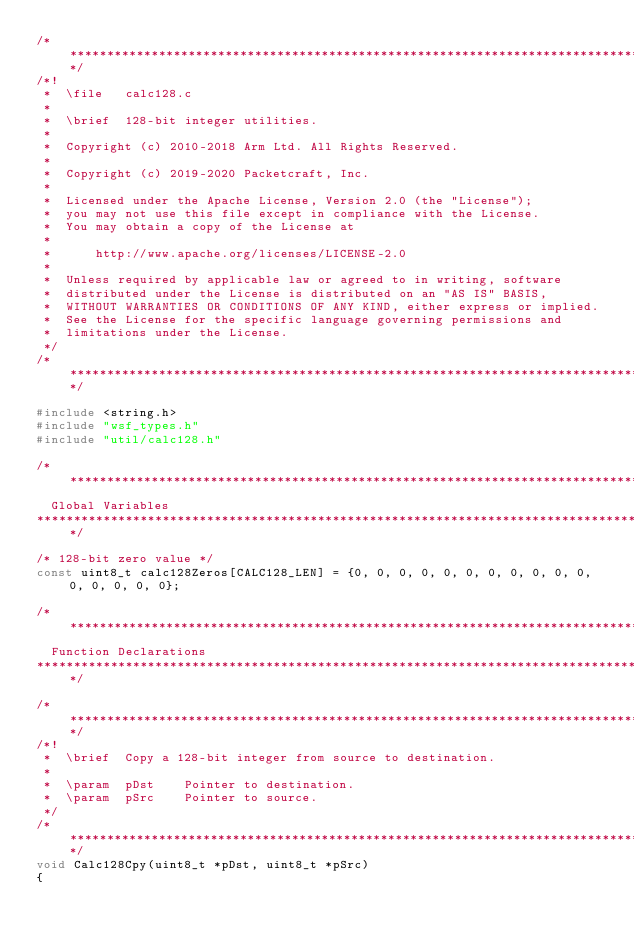<code> <loc_0><loc_0><loc_500><loc_500><_C_>/*************************************************************************************************/
/*!
 *  \file   calc128.c
 *
 *  \brief  128-bit integer utilities.
 *
 *  Copyright (c) 2010-2018 Arm Ltd. All Rights Reserved.
 *
 *  Copyright (c) 2019-2020 Packetcraft, Inc.
 *  
 *  Licensed under the Apache License, Version 2.0 (the "License");
 *  you may not use this file except in compliance with the License.
 *  You may obtain a copy of the License at
 *  
 *      http://www.apache.org/licenses/LICENSE-2.0
 *  
 *  Unless required by applicable law or agreed to in writing, software
 *  distributed under the License is distributed on an "AS IS" BASIS,
 *  WITHOUT WARRANTIES OR CONDITIONS OF ANY KIND, either express or implied.
 *  See the License for the specific language governing permissions and
 *  limitations under the License.
 */
/*************************************************************************************************/

#include <string.h>
#include "wsf_types.h"
#include "util/calc128.h"

/**************************************************************************************************
  Global Variables
**************************************************************************************************/

/* 128-bit zero value */
const uint8_t calc128Zeros[CALC128_LEN] = {0, 0, 0, 0, 0, 0, 0, 0, 0, 0, 0, 0, 0, 0, 0, 0};

/**************************************************************************************************
  Function Declarations
**************************************************************************************************/

/*************************************************************************************************/
/*!
 *  \brief  Copy a 128-bit integer from source to destination.
 *
 *  \param  pDst    Pointer to destination.
 *  \param  pSrc    Pointer to source.
 */
/*************************************************************************************************/
void Calc128Cpy(uint8_t *pDst, uint8_t *pSrc)
{</code> 